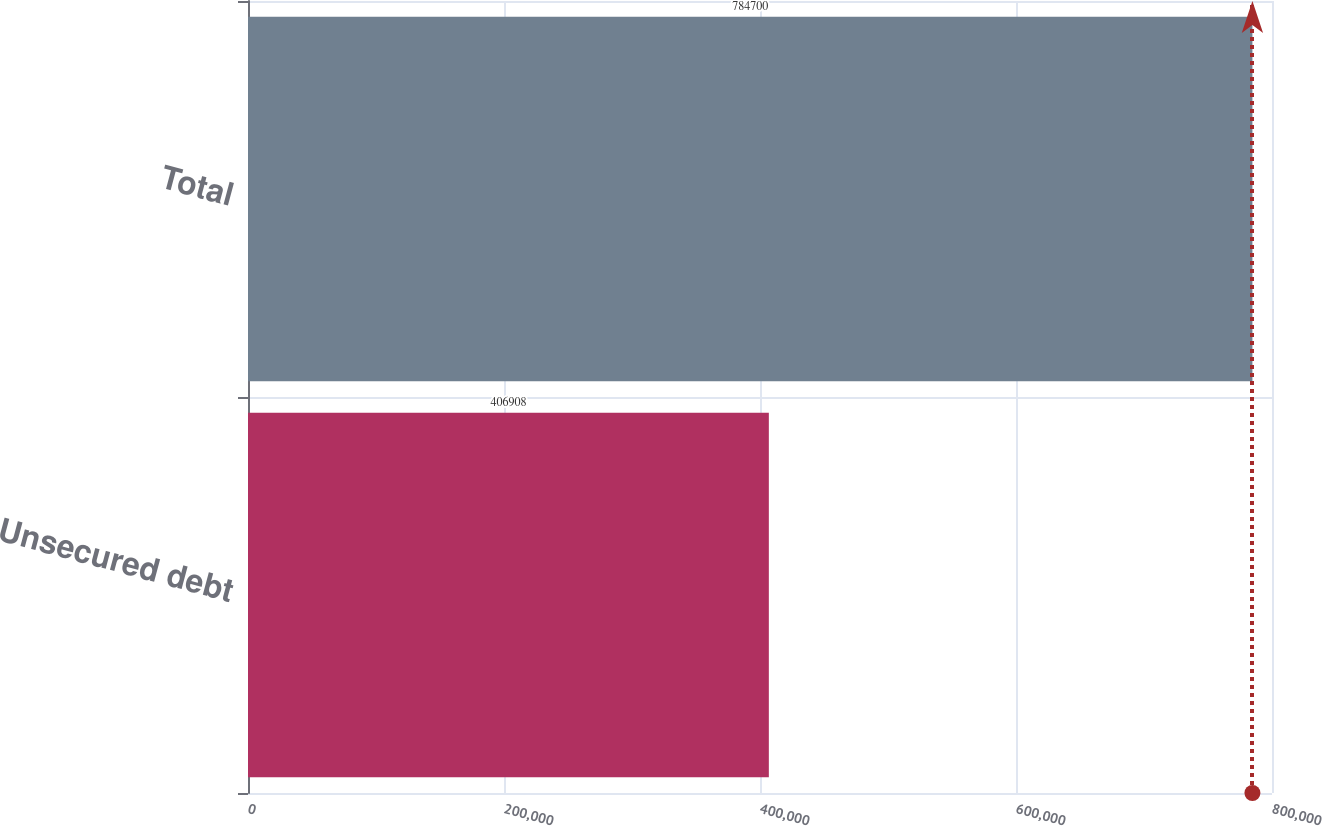<chart> <loc_0><loc_0><loc_500><loc_500><bar_chart><fcel>Unsecured debt<fcel>Total<nl><fcel>406908<fcel>784700<nl></chart> 